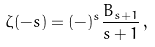<formula> <loc_0><loc_0><loc_500><loc_500>\zeta ( - s ) = ( - ) ^ { s } \frac { B _ { s + 1 } } { s + 1 } \, ,</formula> 